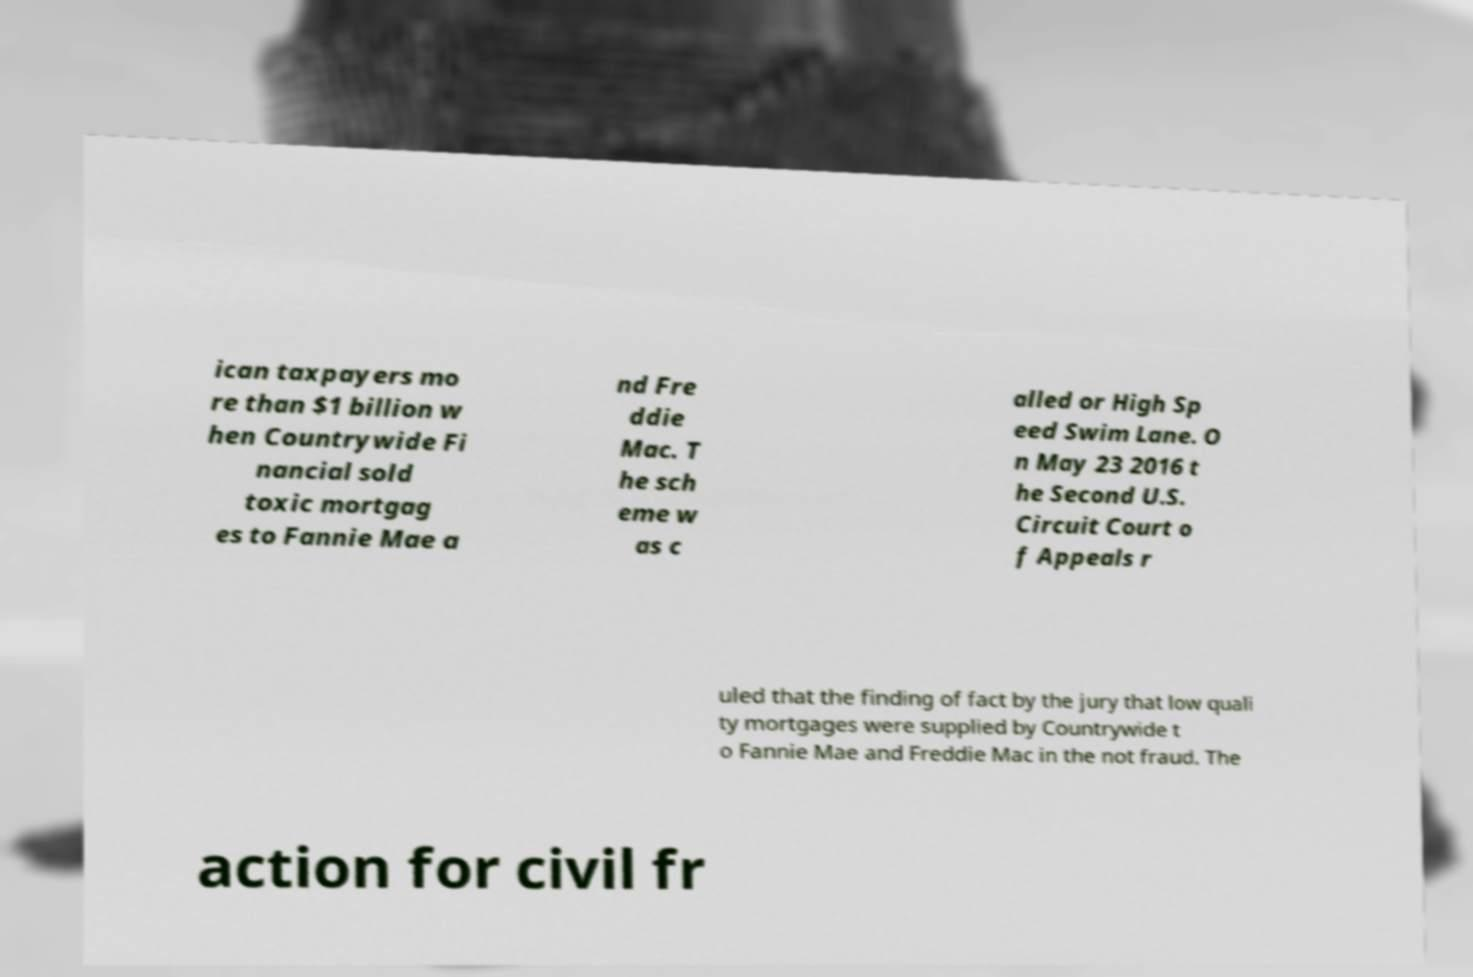Could you extract and type out the text from this image? ican taxpayers mo re than $1 billion w hen Countrywide Fi nancial sold toxic mortgag es to Fannie Mae a nd Fre ddie Mac. T he sch eme w as c alled or High Sp eed Swim Lane. O n May 23 2016 t he Second U.S. Circuit Court o f Appeals r uled that the finding of fact by the jury that low quali ty mortgages were supplied by Countrywide t o Fannie Mae and Freddie Mac in the not fraud. The action for civil fr 